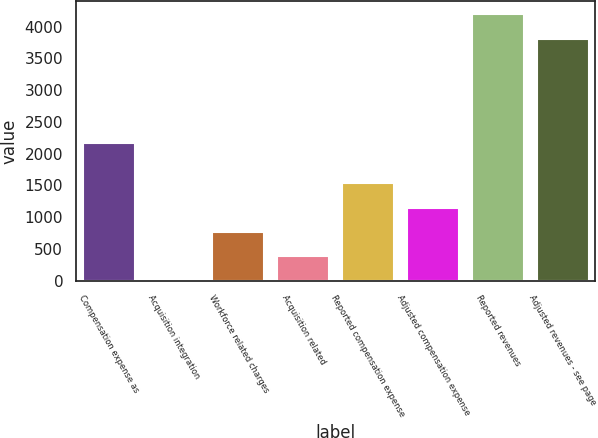Convert chart to OTSL. <chart><loc_0><loc_0><loc_500><loc_500><bar_chart><fcel>Compensation expense as<fcel>Acquisition integration<fcel>Workforce related charges<fcel>Acquisition related<fcel>Reported compensation expense<fcel>Adjusted compensation expense<fcel>Reported revenues<fcel>Adjusted revenues - see page<nl><fcel>2174.2<fcel>7.6<fcel>769.1<fcel>388.35<fcel>1530.6<fcel>1149.85<fcel>4192.45<fcel>3811.7<nl></chart> 